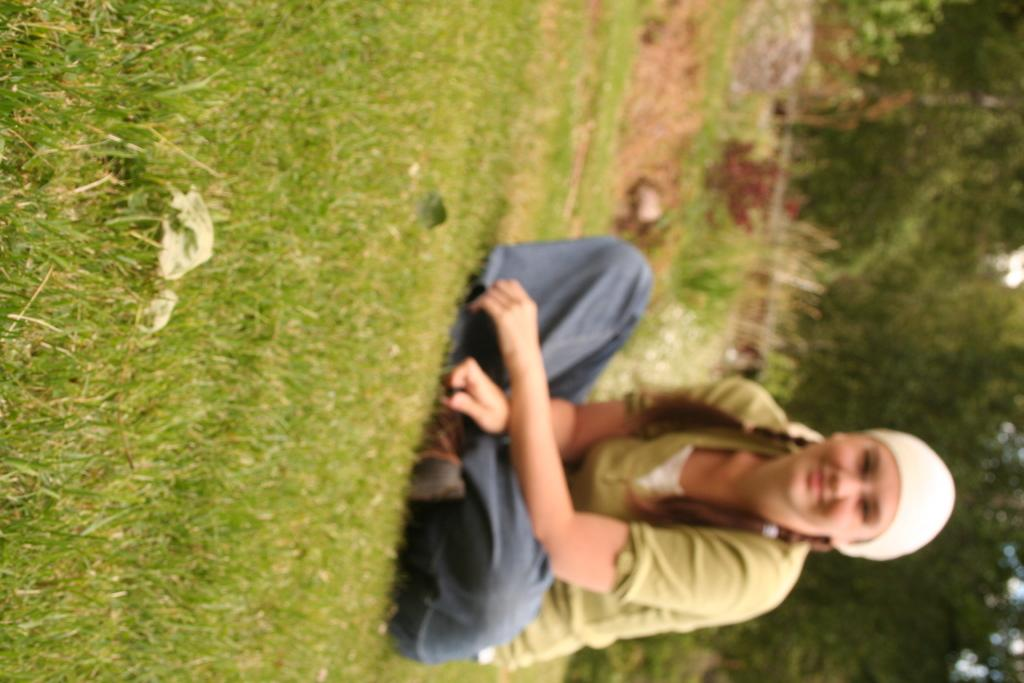Who is the main subject in the image? There is a girl in the image. What is the girl doing in the image? The girl is sitting on the grassland. What can be seen in the background of the image? There is greenery in the background of the image. How many blades of grass are visible in the image? It is not possible to count individual blades of grass in the image, as they are part of the grassland and not individually distinguishable. 